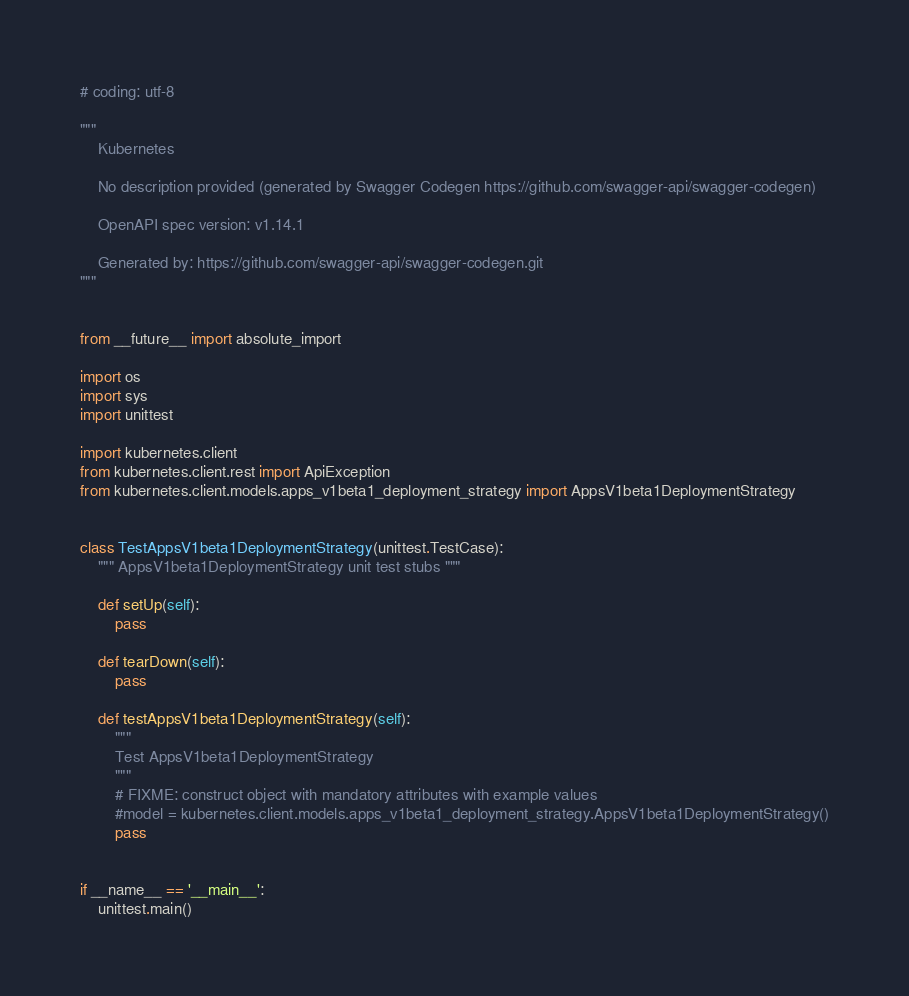<code> <loc_0><loc_0><loc_500><loc_500><_Python_># coding: utf-8

"""
    Kubernetes

    No description provided (generated by Swagger Codegen https://github.com/swagger-api/swagger-codegen)

    OpenAPI spec version: v1.14.1
    
    Generated by: https://github.com/swagger-api/swagger-codegen.git
"""


from __future__ import absolute_import

import os
import sys
import unittest

import kubernetes.client
from kubernetes.client.rest import ApiException
from kubernetes.client.models.apps_v1beta1_deployment_strategy import AppsV1beta1DeploymentStrategy


class TestAppsV1beta1DeploymentStrategy(unittest.TestCase):
    """ AppsV1beta1DeploymentStrategy unit test stubs """

    def setUp(self):
        pass

    def tearDown(self):
        pass

    def testAppsV1beta1DeploymentStrategy(self):
        """
        Test AppsV1beta1DeploymentStrategy
        """
        # FIXME: construct object with mandatory attributes with example values
        #model = kubernetes.client.models.apps_v1beta1_deployment_strategy.AppsV1beta1DeploymentStrategy()
        pass


if __name__ == '__main__':
    unittest.main()
</code> 